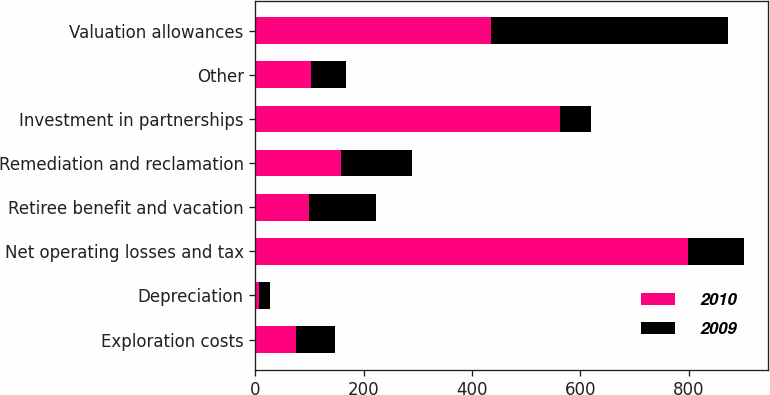Convert chart. <chart><loc_0><loc_0><loc_500><loc_500><stacked_bar_chart><ecel><fcel>Exploration costs<fcel>Depreciation<fcel>Net operating losses and tax<fcel>Retiree benefit and vacation<fcel>Remediation and reclamation<fcel>Investment in partnerships<fcel>Other<fcel>Valuation allowances<nl><fcel>2010<fcel>75<fcel>6<fcel>799<fcel>98<fcel>158<fcel>563<fcel>103<fcel>435<nl><fcel>2009<fcel>72<fcel>21<fcel>103<fcel>124<fcel>132<fcel>57<fcel>64<fcel>437<nl></chart> 